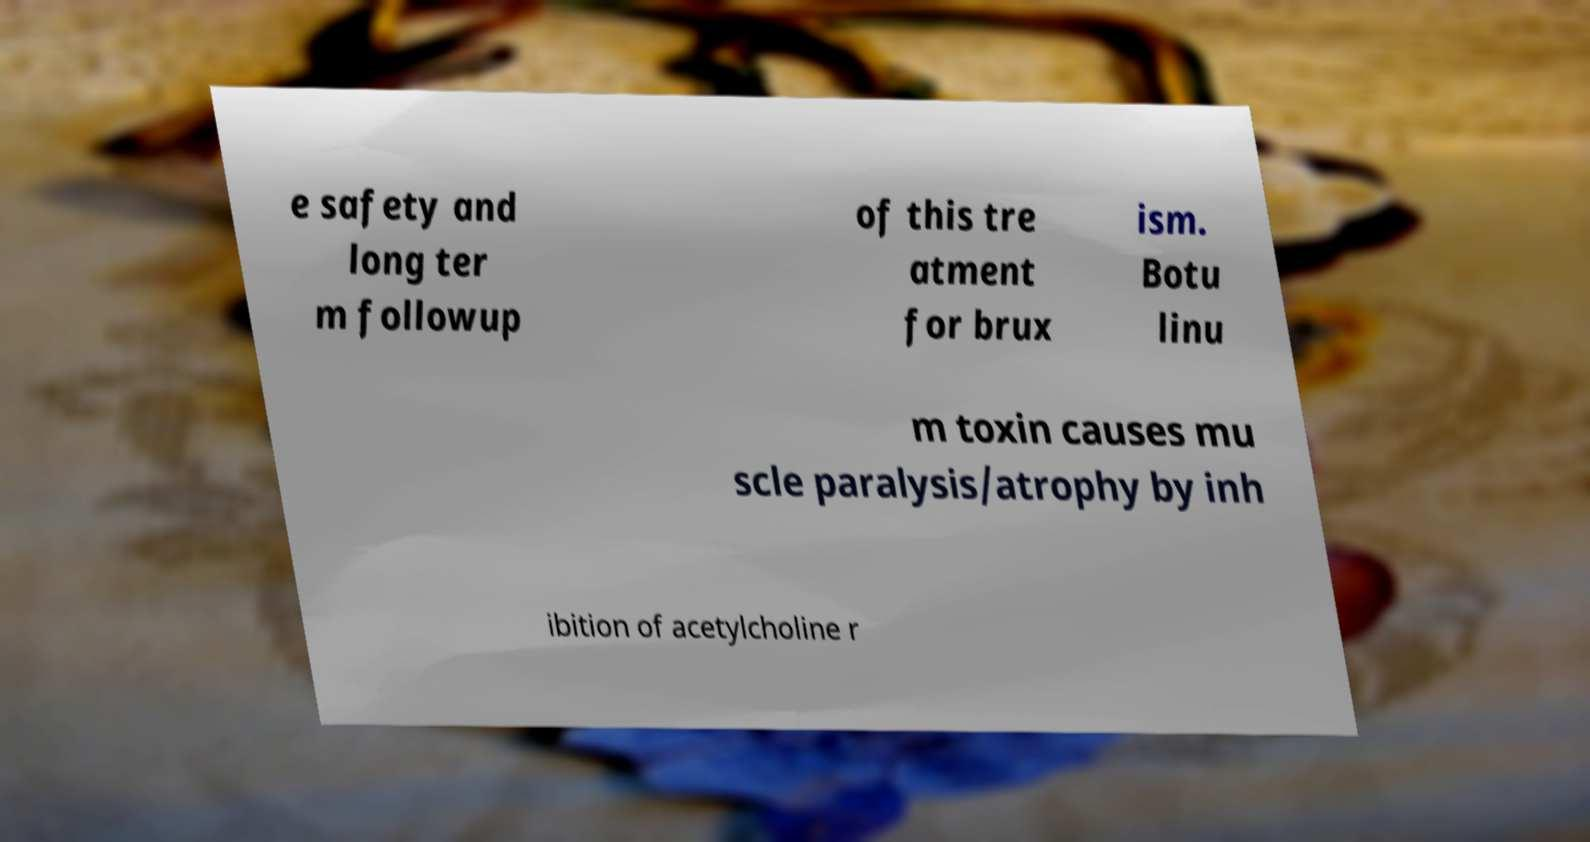Can you accurately transcribe the text from the provided image for me? e safety and long ter m followup of this tre atment for brux ism. Botu linu m toxin causes mu scle paralysis/atrophy by inh ibition of acetylcholine r 